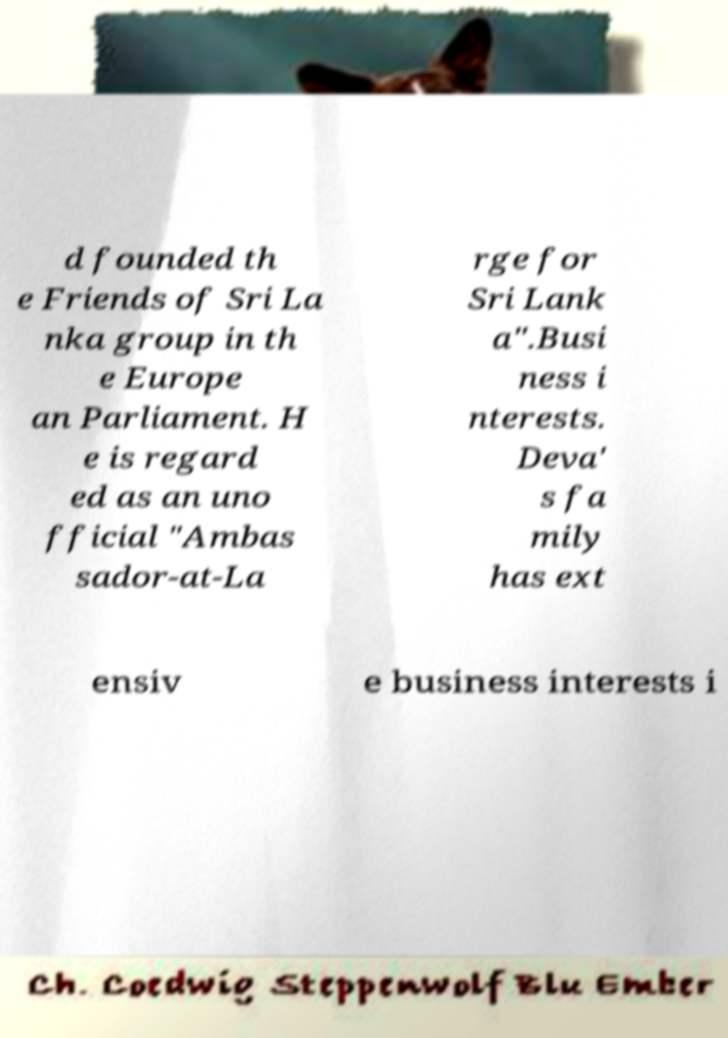For documentation purposes, I need the text within this image transcribed. Could you provide that? d founded th e Friends of Sri La nka group in th e Europe an Parliament. H e is regard ed as an uno fficial "Ambas sador-at-La rge for Sri Lank a".Busi ness i nterests. Deva' s fa mily has ext ensiv e business interests i 